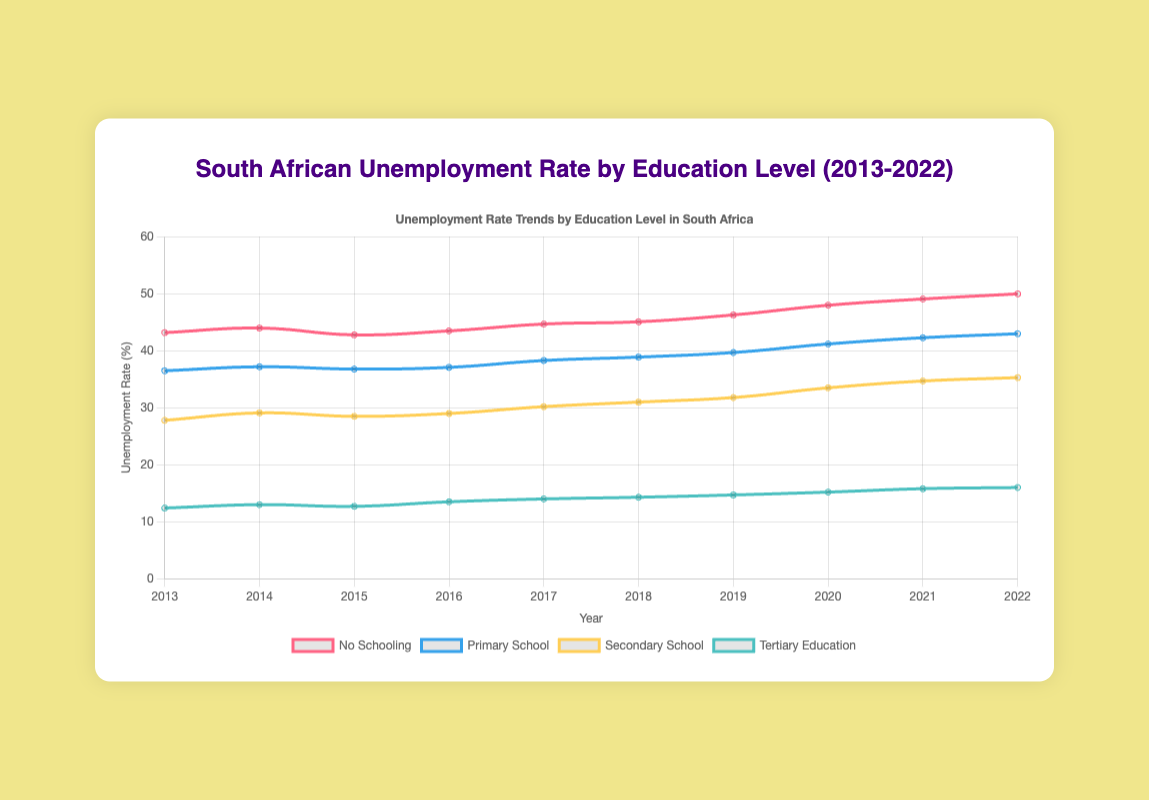What is the overall trend in unemployment rates for those with tertiary education from 2013 to 2022? Looking at the plot, the trend for tertiary education shows an upward movement across the decade. From 12.4% in 2013, the rate increased to 16.0% in 2022, indicating an increasing trend.
Answer: Increasing Which year had the highest unemployment rate for individuals with no schooling? By examining the plot, 2022 has the highest unemployment rate for individuals with no schooling, at 50.0%.
Answer: 2022 Compare the unemployment rates of primary school and secondary school education in 2022. Which had a higher rate? The plot shows that in 2022, the unemployment rate for primary school education was 43.0%, while for secondary school education, it was 35.3%. Thus, primary school education had a higher rate.
Answer: Primary school What was the difference in the unemployment rate between primary school and tertiary education in 2020? From the plot, the unemployment rate for primary school in 2020 was 41.2%, and for tertiary education, it was 15.2%. The difference is 41.2% - 15.2% = 26.0%.
Answer: 26.0% On average, what was the unemployment rate for secondary school education between 2018 and 2020? The unemployment rates for secondary school education between 2018 and 2020 were 31.0%, 31.8%, and 33.5%. The average is (31.0 + 31.8 + 33.5) / 3 = 32.1%.
Answer: 32.1% How did the unemployment rate for no schooling change from 2019 to 2022? In 2019, the unemployment rate for no schooling was 46.3%, and in 2022 it was 50.0%. The increase is 50.0% - 46.3% = 3.7%.
Answer: Increased by 3.7% Which education level had the smallest increase in unemployment rate from 2013 to 2022? Reviewing the plot, tertiary education had the smallest increase in unemployment rate, from 12.4% in 2013 to 16.0% in 2022, an increase of 3.6%.
Answer: Tertiary education In which year did the employment rate exceed 40% for primary school education? The plot shows that the unemployment rate for primary school education exceeded 40% for the first time in 2020 with a rate of 41.2%.
Answer: 2020 What is the median unemployment rate for those with secondary school education over the decade? To find the median, list the unemployment rates from 2013 to 2022: 27.8, 29.1, 28.5, 29.0, 30.2, 31.0, 31.8, 33.5, 34.7, 35.3. The median is the average of the 5th and 6th values, (30.2 + 31.0) / 2 = 30.6%.
Answer: 30.6% 